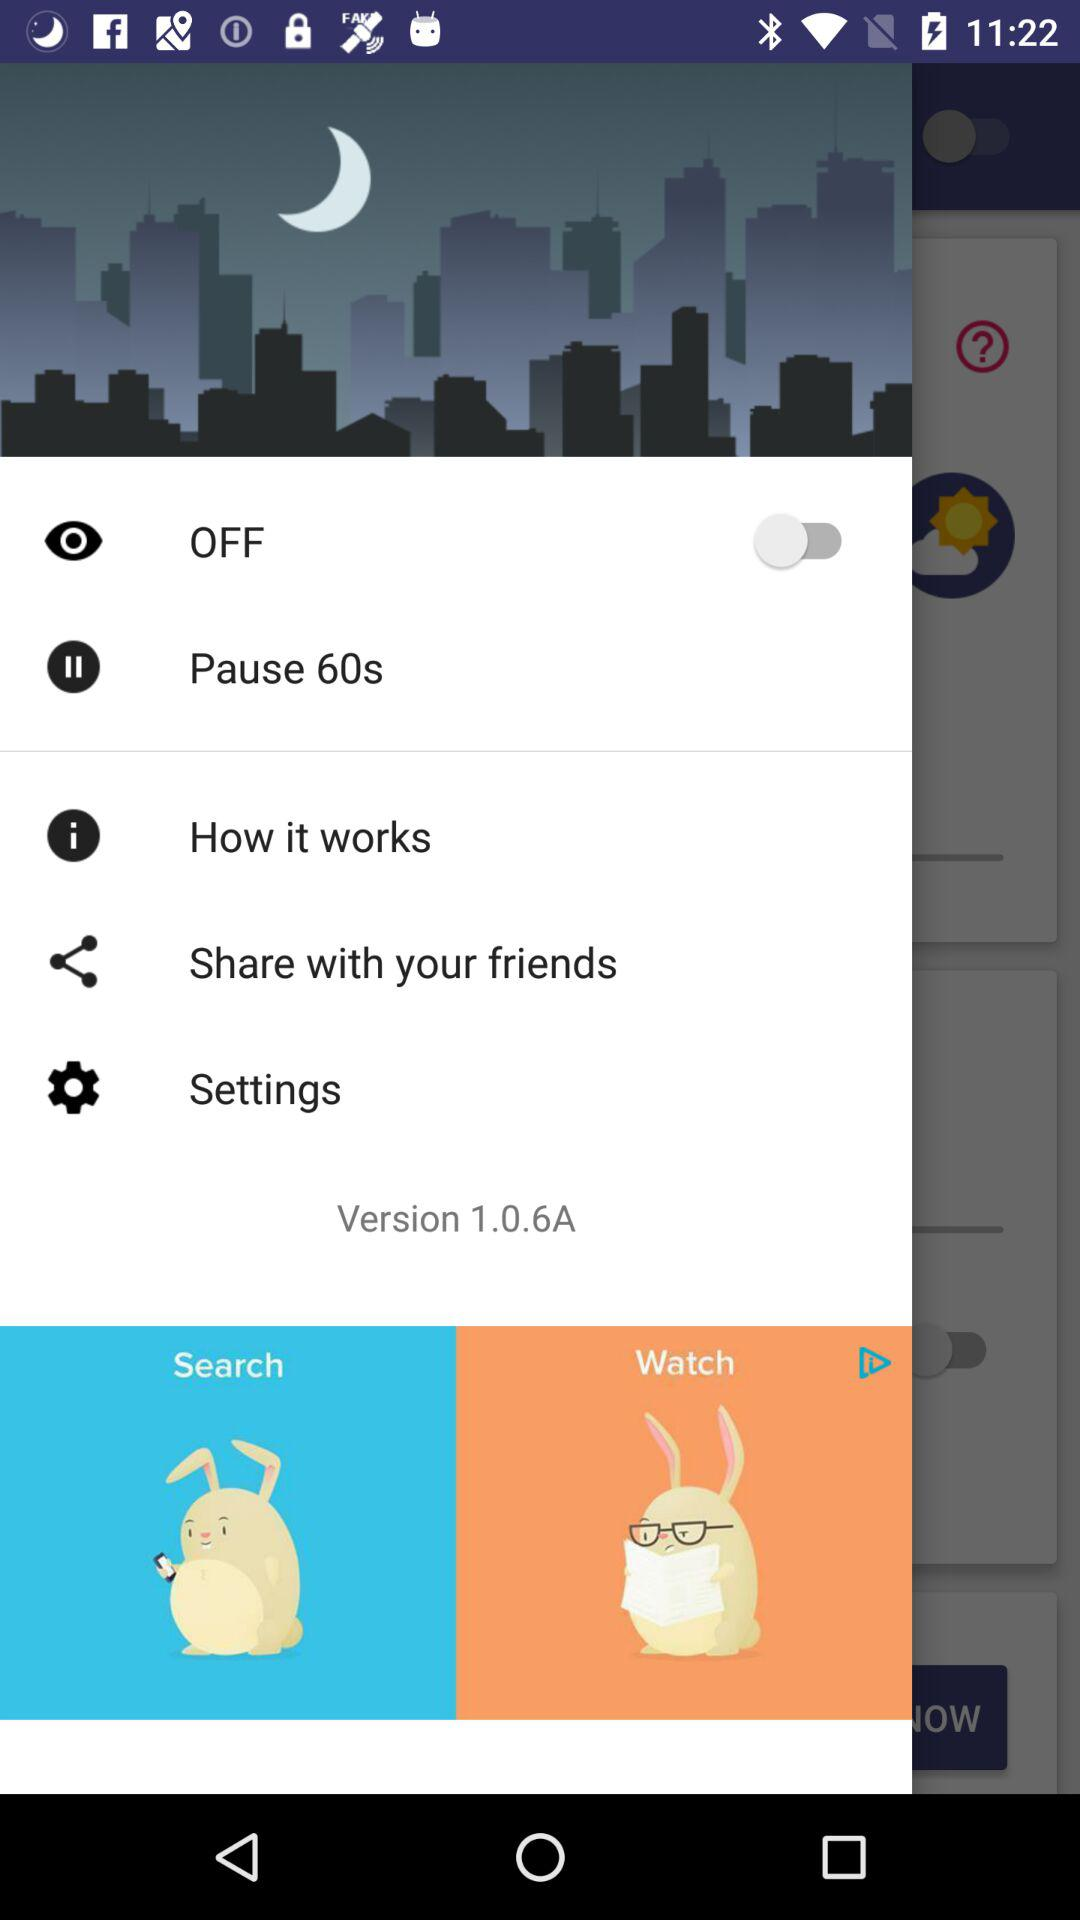What is the version? The version is 1.0.6A. 